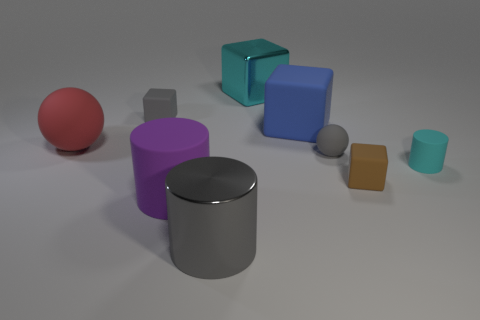What number of blue things have the same size as the blue cube?
Your answer should be compact. 0. Does the gray cylinder have the same size as the cyan metal cube?
Keep it short and to the point. Yes. There is a rubber cube that is behind the gray sphere and to the right of the large cyan metal block; what size is it?
Your answer should be very brief. Large. Are there more tiny blocks in front of the cyan rubber cylinder than shiny objects behind the gray rubber sphere?
Offer a terse response. No. The other small rubber object that is the same shape as the small brown matte thing is what color?
Offer a very short reply. Gray. There is a small rubber cube in front of the cyan rubber cylinder; is its color the same as the metallic cube?
Keep it short and to the point. No. What number of small matte cylinders are there?
Make the answer very short. 1. Do the cyan cube that is behind the large gray metal object and the big purple cylinder have the same material?
Your answer should be very brief. No. Is there any other thing that has the same material as the gray sphere?
Provide a succinct answer. Yes. What number of blue matte things are behind the large block behind the matte block left of the large metal block?
Keep it short and to the point. 0. 